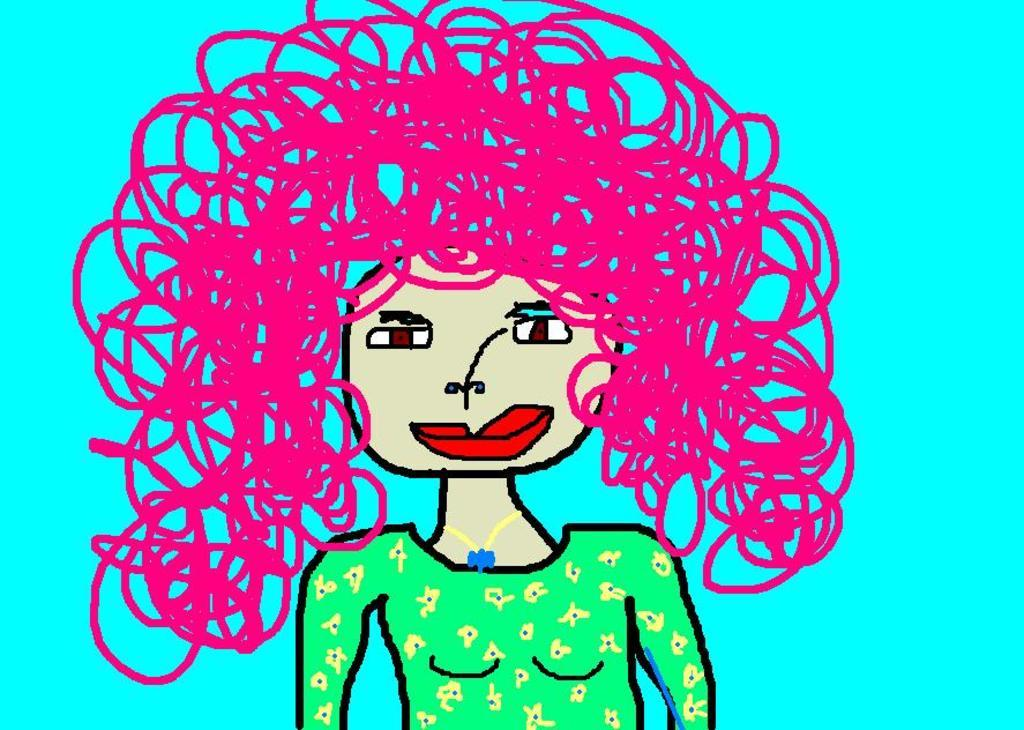What is the main subject of the art piece in the image? The art piece depicts a woman. What color is the background of the art piece? The background of the art piece is blue in color. Can you describe the alley where the woman is standing in the image? There is no alley present in the image; it contains an art piece depicting a woman with a blue background. 